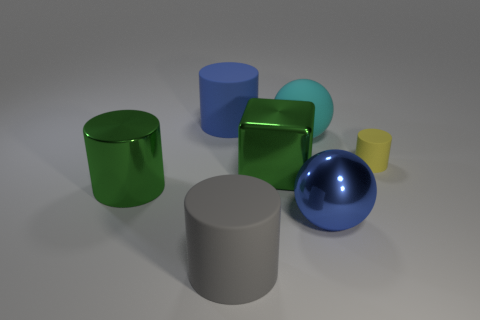What number of other things are there of the same color as the big shiny cylinder?
Offer a very short reply. 1. What number of spheres are either blue rubber things or big cyan rubber objects?
Offer a terse response. 1. What number of cylinders are both in front of the tiny yellow rubber cylinder and behind the yellow matte cylinder?
Ensure brevity in your answer.  0. There is a big sphere in front of the large green metallic cylinder; what is its color?
Your answer should be very brief. Blue. What is the size of the yellow cylinder that is the same material as the large blue cylinder?
Offer a terse response. Small. There is a sphere that is on the right side of the rubber sphere; how many big blue rubber objects are in front of it?
Give a very brief answer. 0. There is a blue rubber cylinder; how many rubber spheres are behind it?
Give a very brief answer. 0. What is the color of the cylinder that is to the right of the large matte object in front of the large metallic thing on the right side of the rubber sphere?
Offer a terse response. Yellow. Do the cylinder that is behind the small yellow object and the large ball that is on the right side of the large cyan rubber thing have the same color?
Ensure brevity in your answer.  Yes. There is a large metallic thing left of the big rubber thing in front of the blue metal ball; what is its shape?
Keep it short and to the point. Cylinder. 